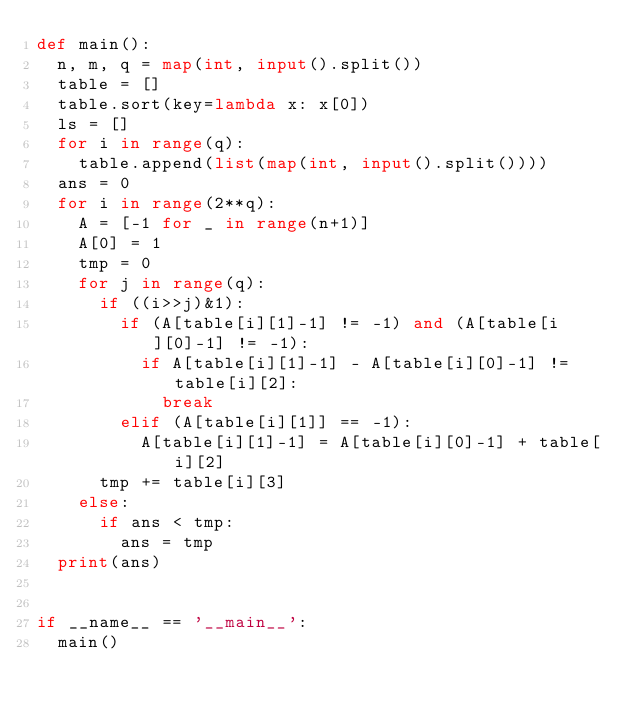<code> <loc_0><loc_0><loc_500><loc_500><_Python_>def main():
  n, m, q = map(int, input().split())
  table = []
  table.sort(key=lambda x: x[0])
  ls = []
  for i in range(q):
    table.append(list(map(int, input().split())))
  ans = 0
  for i in range(2**q):
    A = [-1 for _ in range(n+1)] 
    A[0] = 1
    tmp = 0
    for j in range(q):
      if ((i>>j)&1):
        if (A[table[i][1]-1] != -1) and (A[table[i][0]-1] != -1):
          if A[table[i][1]-1] - A[table[i][0]-1] != table[i][2]:
            break
        elif (A[table[i][1]] == -1):
          A[table[i][1]-1] = A[table[i][0]-1] + table[i][2]
      tmp += table[i][3]
    else:
      if ans < tmp:
        ans = tmp
  print(ans)
  
  
if __name__ == '__main__':
  main()</code> 